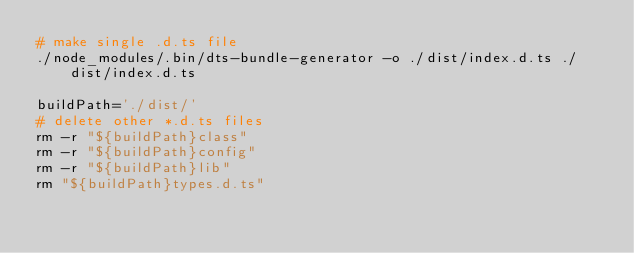Convert code to text. <code><loc_0><loc_0><loc_500><loc_500><_Bash_># make single .d.ts file
./node_modules/.bin/dts-bundle-generator -o ./dist/index.d.ts ./dist/index.d.ts

buildPath='./dist/'
# delete other *.d.ts files
rm -r "${buildPath}class"
rm -r "${buildPath}config"
rm -r "${buildPath}lib"
rm "${buildPath}types.d.ts"</code> 